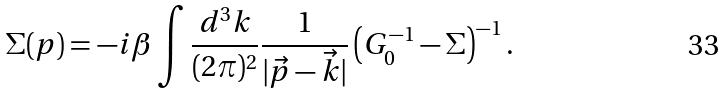Convert formula to latex. <formula><loc_0><loc_0><loc_500><loc_500>\Sigma ( p ) = - i \beta \int \frac { d ^ { 3 } k } { ( 2 \pi ) ^ { 2 } } \frac { 1 } { | \vec { p } - \vec { k } | } \left ( G _ { 0 } ^ { - 1 } - \Sigma \right ) ^ { - 1 } .</formula> 